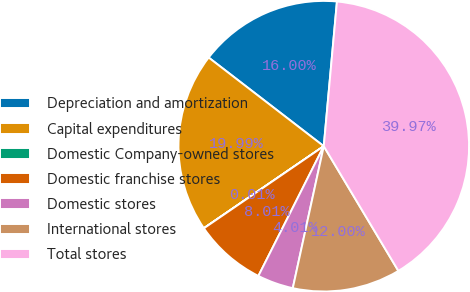<chart> <loc_0><loc_0><loc_500><loc_500><pie_chart><fcel>Depreciation and amortization<fcel>Capital expenditures<fcel>Domestic Company-owned stores<fcel>Domestic franchise stores<fcel>Domestic stores<fcel>International stores<fcel>Total stores<nl><fcel>16.0%<fcel>19.99%<fcel>0.01%<fcel>8.01%<fcel>4.01%<fcel>12.0%<fcel>39.97%<nl></chart> 